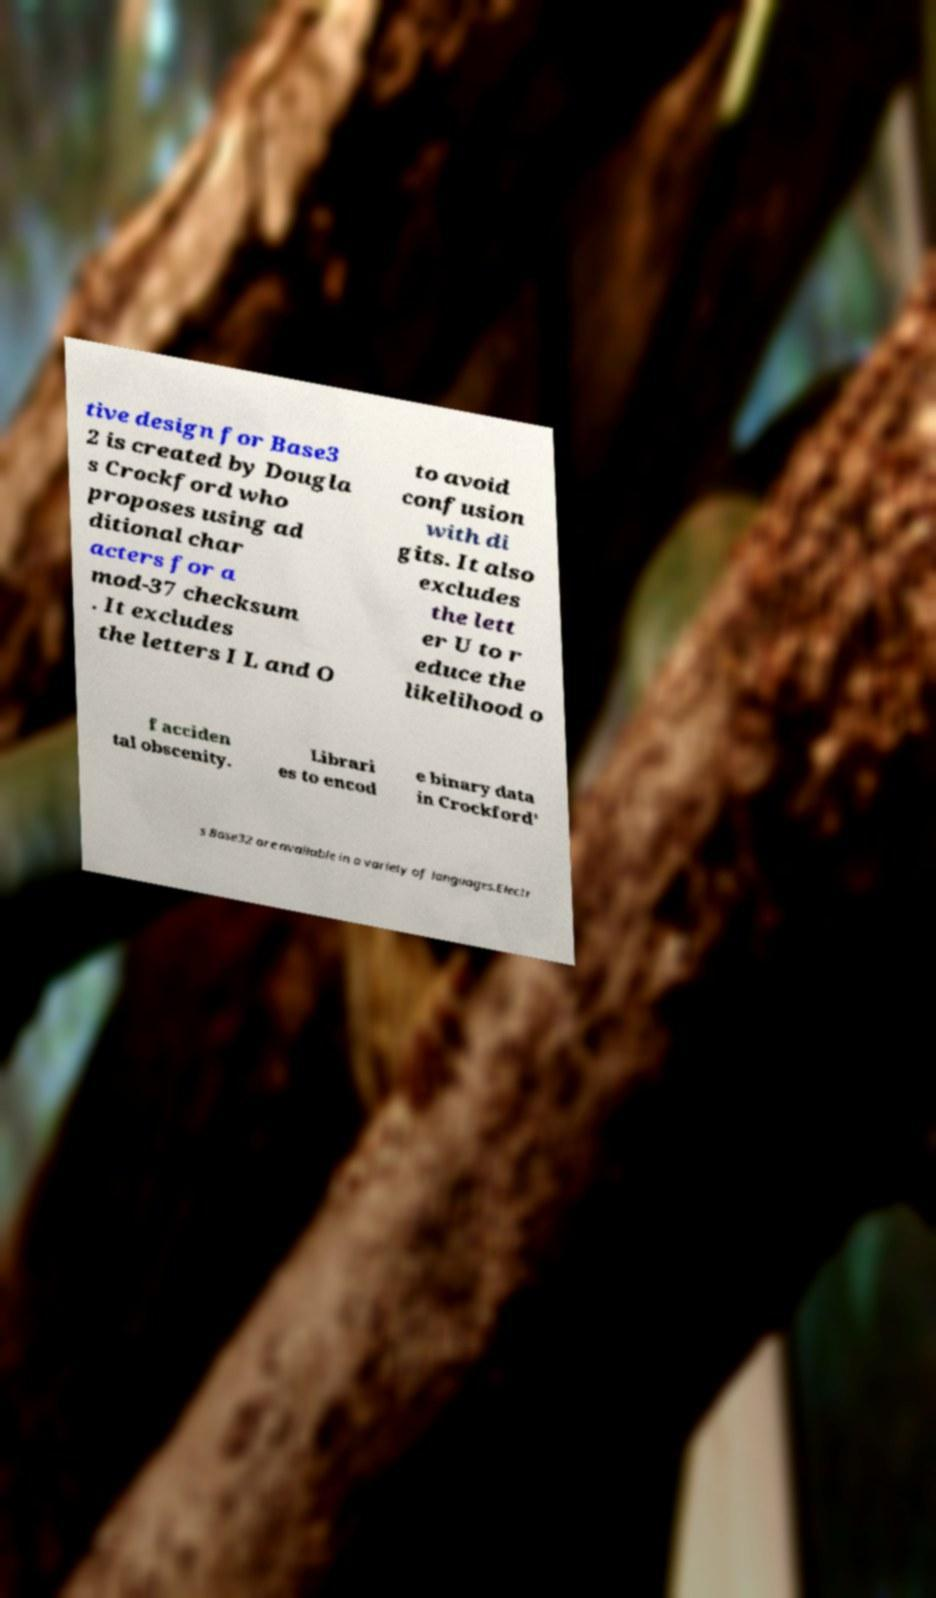What messages or text are displayed in this image? I need them in a readable, typed format. tive design for Base3 2 is created by Dougla s Crockford who proposes using ad ditional char acters for a mod-37 checksum . It excludes the letters I L and O to avoid confusion with di gits. It also excludes the lett er U to r educe the likelihood o f acciden tal obscenity. Librari es to encod e binary data in Crockford' s Base32 are available in a variety of languages.Electr 